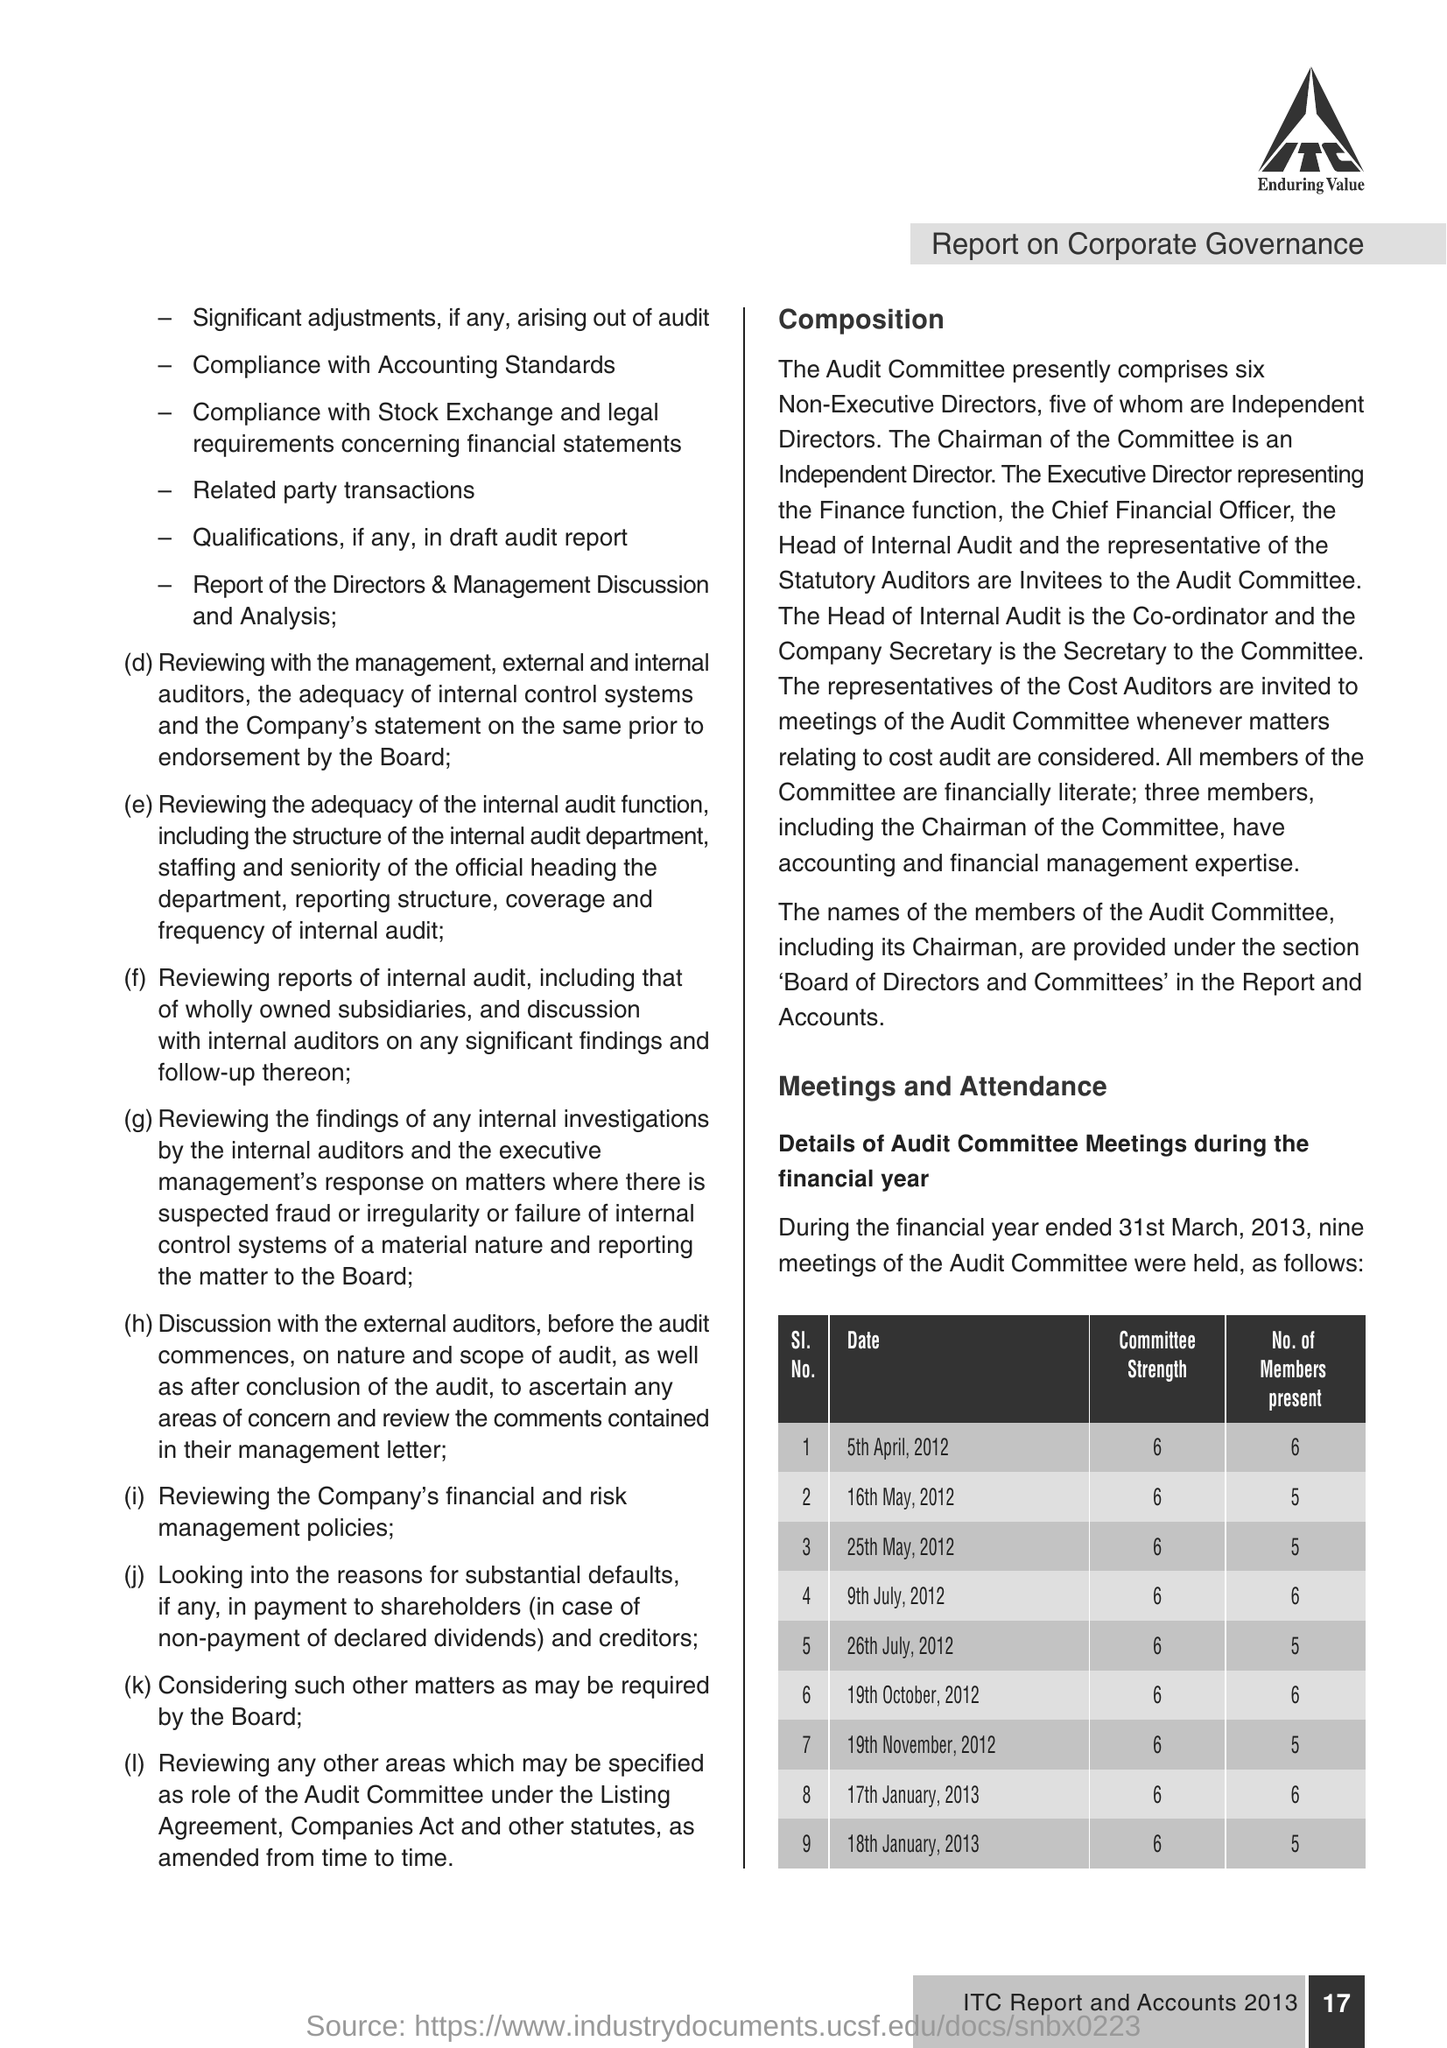Mention a couple of crucial points in this snapshot. On July 9th, 2012, the committee had a certain strength. On May 16, 2012, there were five members present. 